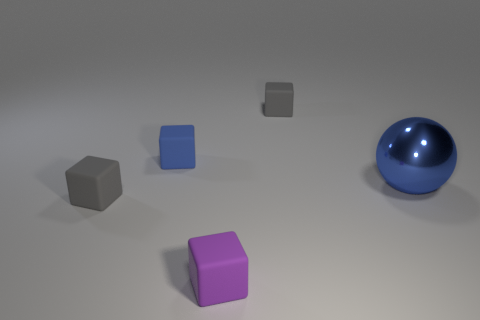Subtract all cyan spheres. How many gray cubes are left? 2 Add 2 large metal things. How many objects exist? 7 Subtract all tiny purple blocks. How many blocks are left? 3 Subtract all purple blocks. How many blocks are left? 3 Subtract all spheres. How many objects are left? 4 Subtract all cyan cubes. Subtract all purple balls. How many cubes are left? 4 Subtract all big yellow cylinders. Subtract all small blue matte cubes. How many objects are left? 4 Add 3 blue metallic spheres. How many blue metallic spheres are left? 4 Add 2 tiny green metal spheres. How many tiny green metal spheres exist? 2 Subtract 0 purple spheres. How many objects are left? 5 